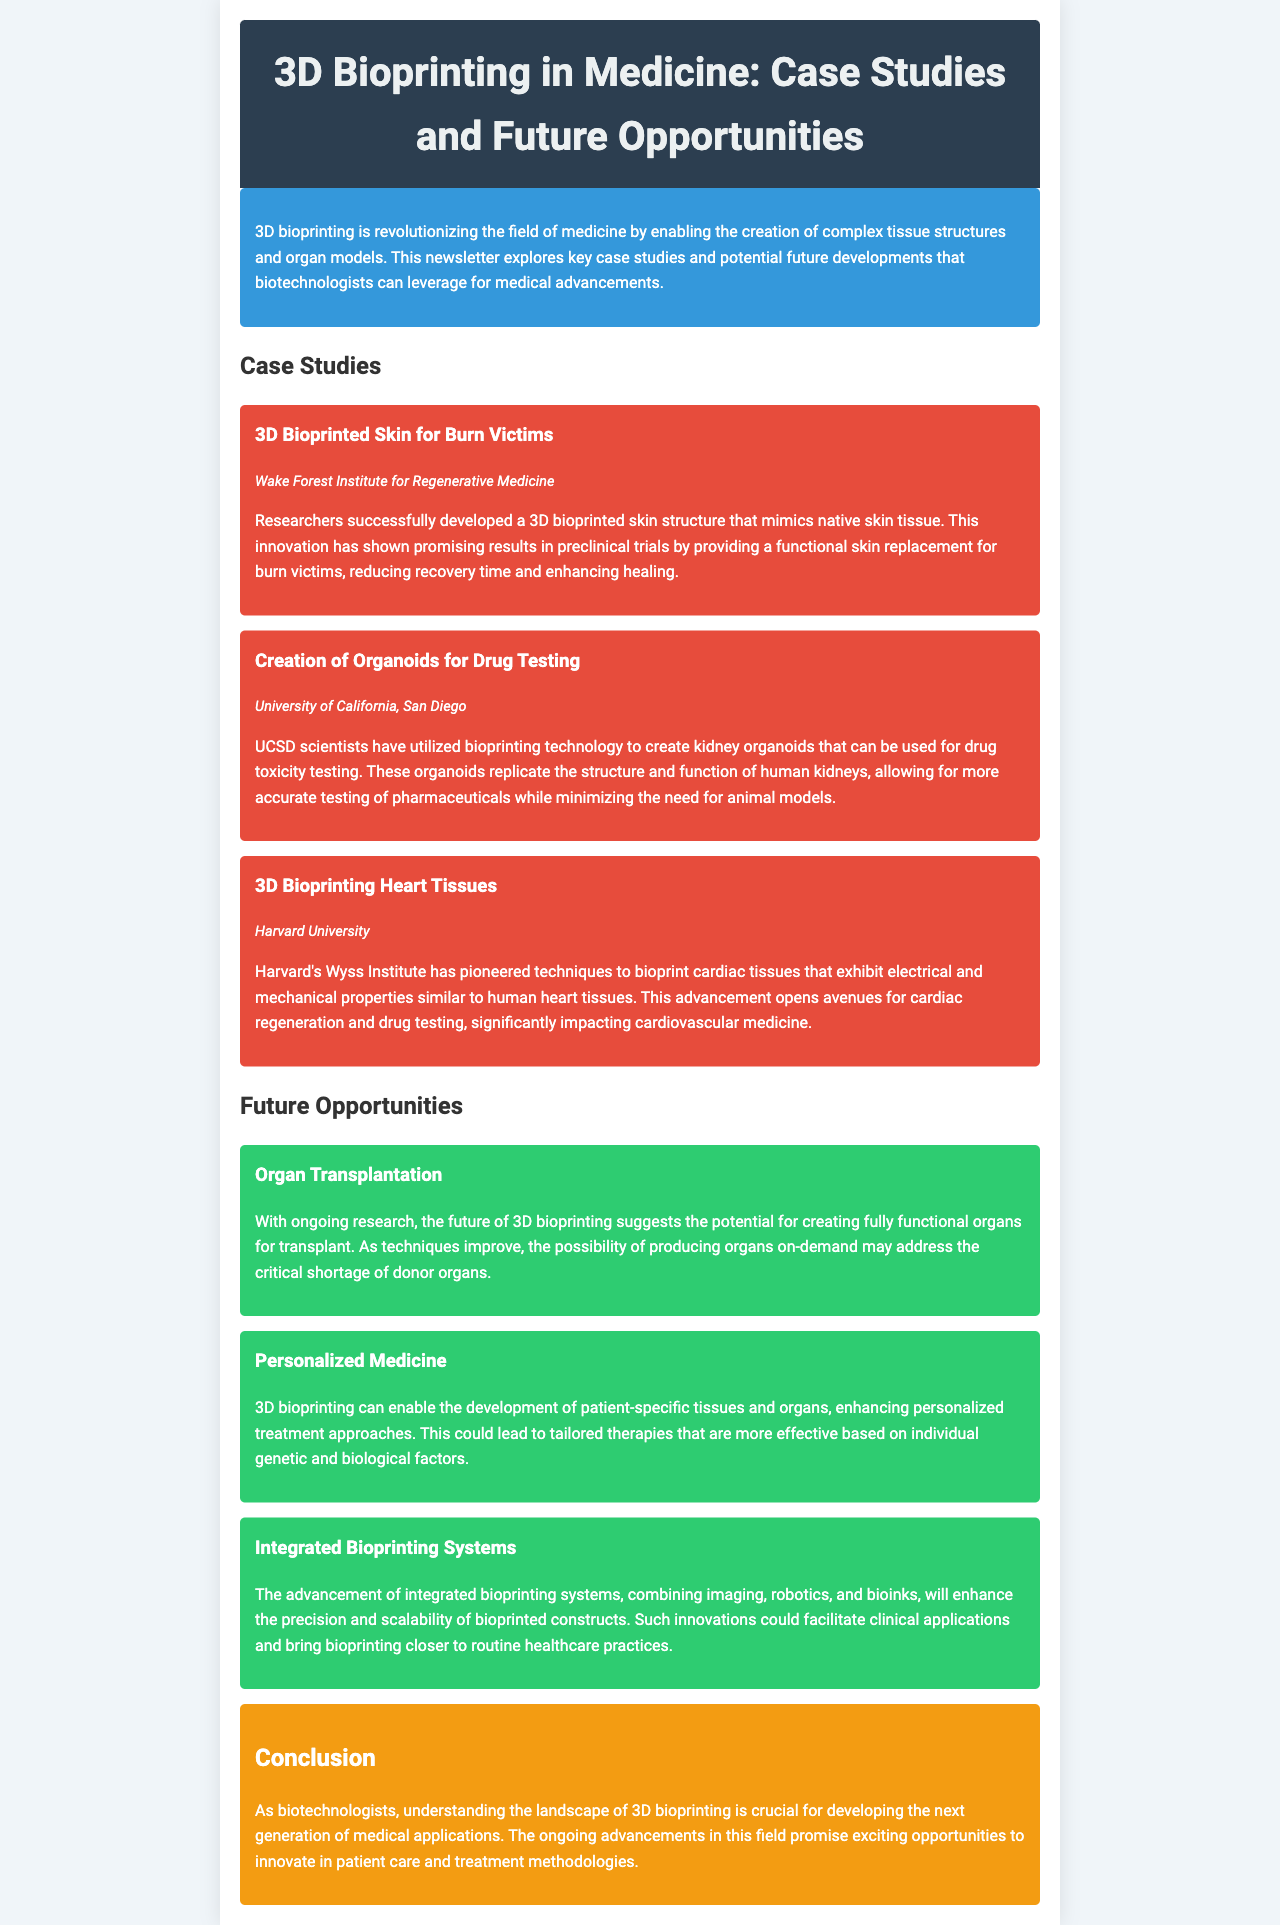What is the title of the newsletter? The title is mentioned in the header of the document.
Answer: 3D Bioprinting in Medicine: Case Studies and Future Opportunities Which organization developed 3D bioprinted skin? The organization is specified in the case study section of the document.
Answer: Wake Forest Institute for Regenerative Medicine What is the main application of kidney organoids created at UCSD? This is explained in the case study section about organoids.
Answer: Drug toxicity testing What type of tissues did Harvard's Wyss Institute bioprint? The specific type of tissues is outlined in the case study section.
Answer: Cardiac tissues What is a potential future application of 3D bioprinting mentioned in the newsletter? The future opportunities section highlights specific applications.
Answer: Organ transplantation What is the main benefit of personalized medicine in 3D bioprinting? This is discussed in the future opportunities section.
Answer: Patient-specific tissues How does integrated bioprinting enhance bioprinted constructs? The impact of integrated systems is detailed in the future opportunities section.
Answer: Enhances precision and scalability What color is the conclusion section of the newsletter? The color of the conclusion section is described in the document's styling details.
Answer: Orange 